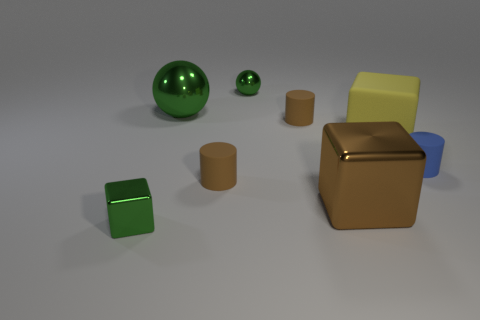What color is the small thing that is to the right of the matte cylinder that is behind the big block that is to the right of the large brown thing?
Offer a very short reply. Blue. What is the material of the tiny green object that is the same shape as the yellow matte thing?
Provide a short and direct response. Metal. How many green matte balls are the same size as the brown shiny cube?
Offer a terse response. 0. How many tiny cyan matte objects are there?
Make the answer very short. 0. Is the tiny cube made of the same material as the cylinder that is behind the large yellow cube?
Make the answer very short. No. How many yellow objects are cylinders or big matte objects?
Offer a very short reply. 1. The other block that is the same material as the green block is what size?
Keep it short and to the point. Large. What number of big matte objects have the same shape as the tiny blue rubber object?
Provide a succinct answer. 0. Are there more cylinders that are on the right side of the large yellow rubber thing than big yellow rubber cubes to the left of the large green metal sphere?
Your answer should be compact. Yes. There is a tiny metal ball; is its color the same as the metal block that is in front of the big brown metal object?
Ensure brevity in your answer.  Yes. 